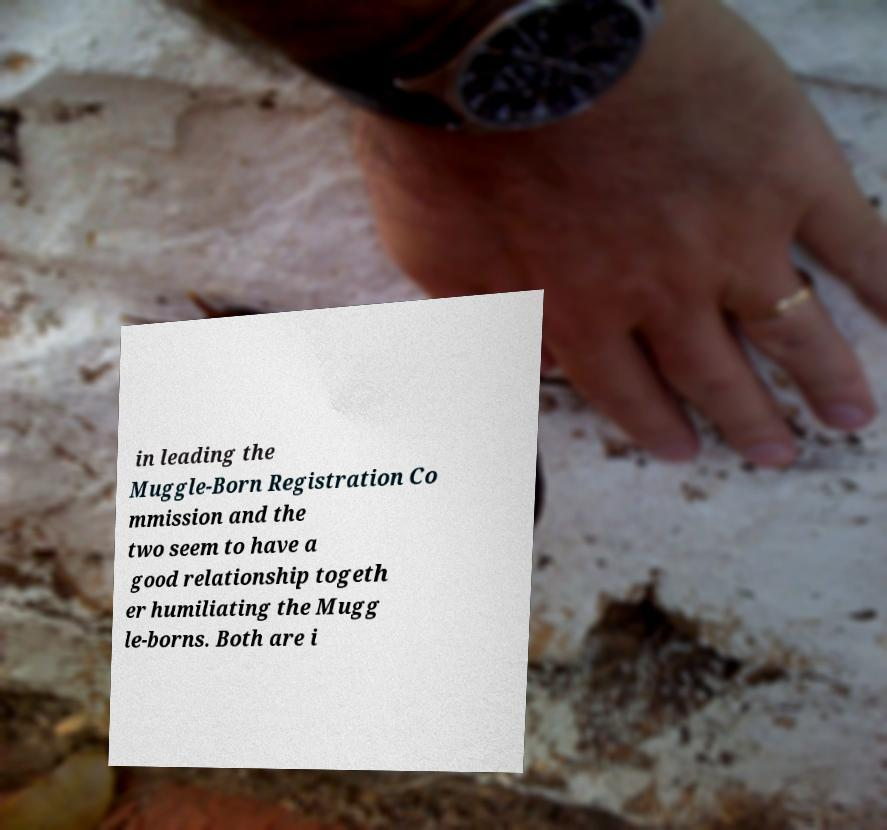Please read and relay the text visible in this image. What does it say? in leading the Muggle-Born Registration Co mmission and the two seem to have a good relationship togeth er humiliating the Mugg le-borns. Both are i 